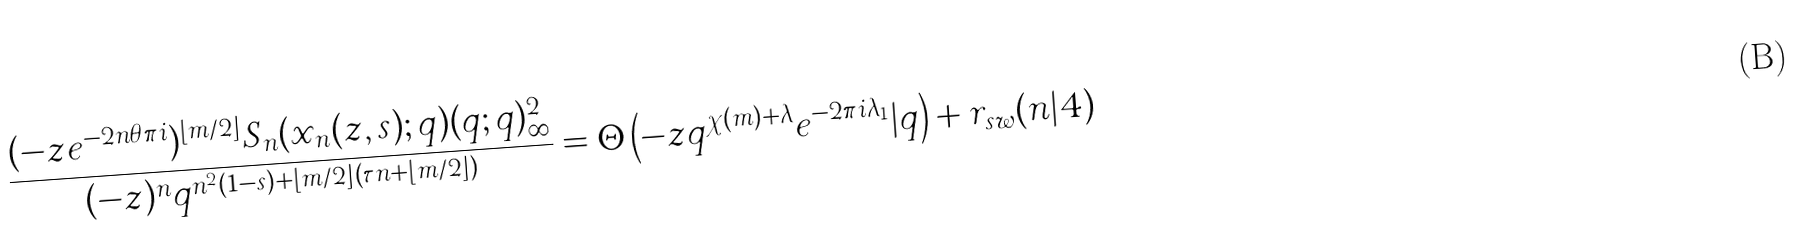Convert formula to latex. <formula><loc_0><loc_0><loc_500><loc_500>\frac { ( - z e ^ { - 2 n \theta \pi i } ) ^ { \left \lfloor m / 2 \right \rfloor } S _ { n } ( x _ { n } ( z , s ) ; q ) ( q ; q ) _ { \infty } ^ { 2 } } { ( - z ) ^ { n } q ^ { n ^ { 2 } ( 1 - s ) + \left \lfloor m / 2 \right \rfloor \left ( \tau n + \left \lfloor m / 2 \right \rfloor \right ) } } = \Theta \left ( - z q ^ { \chi ( m ) + \lambda } e ^ { - 2 \pi i \lambda _ { 1 } } | q \right ) + r _ { s w } ( n | 4 )</formula> 